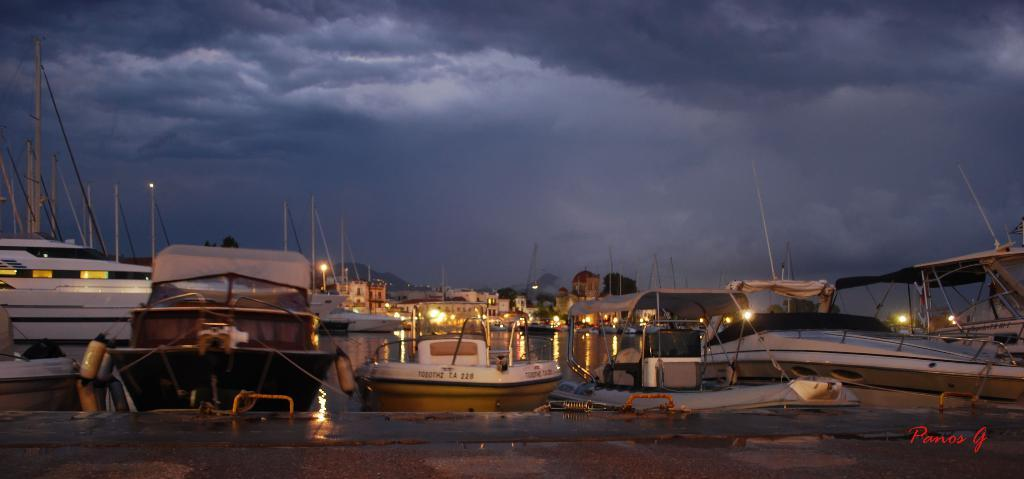What type of vehicles can be seen in the image? There are boats in the image. What structures are present in the image? There are poles in the image. What can be used for illumination in the image? There are lights in the image. What other objects can be seen in the image besides boats, poles, and lights? There are other objects in the image. What is visible in the background of the image? The sky is visible in the background of the image. Is there any text or marking in the image? Yes, there is a watermark in the bottom right corner of the image. Can you tell me how many letters are written on the wing in the image? There is no wing or letters written on it in the image. What type of bell can be seen hanging from the pole in the image? There is no bell present in the image; only boats, poles, lights, and other objects are visible. 